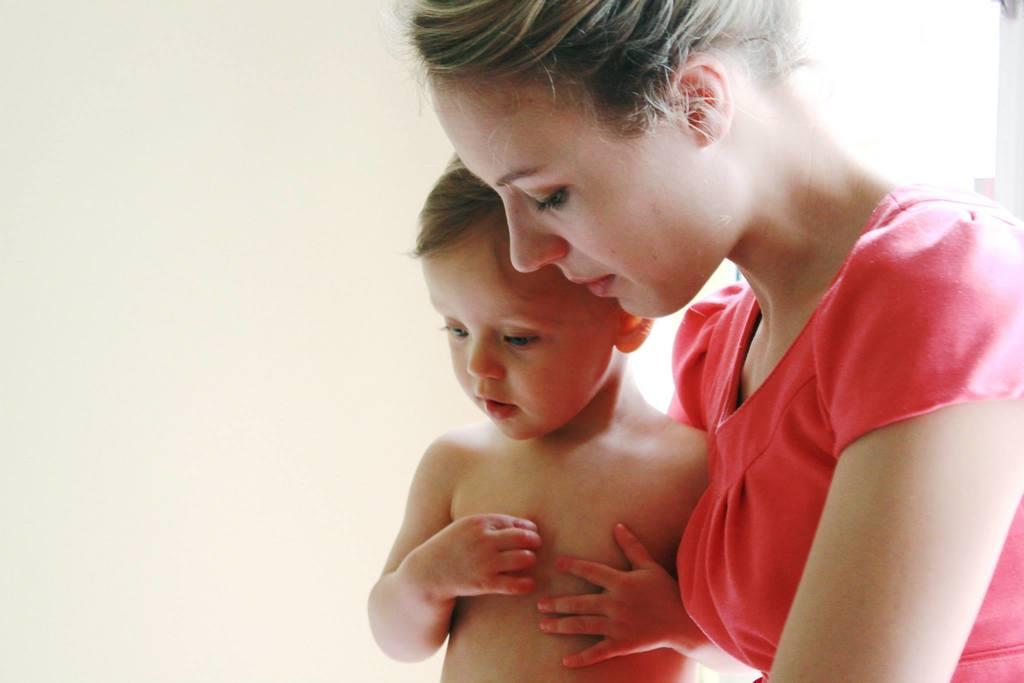Who are the people in the image? There is a woman and a boy in the image. What can be seen in the background of the image? There is a wall in the background of the image. What type of feather can be seen on the boy's head in the image? There is no feather present on the boy's head in the image. How does the woman plan to join the boy in the image? The image does not depict any action or intention to join, so it cannot be determined from the image. 